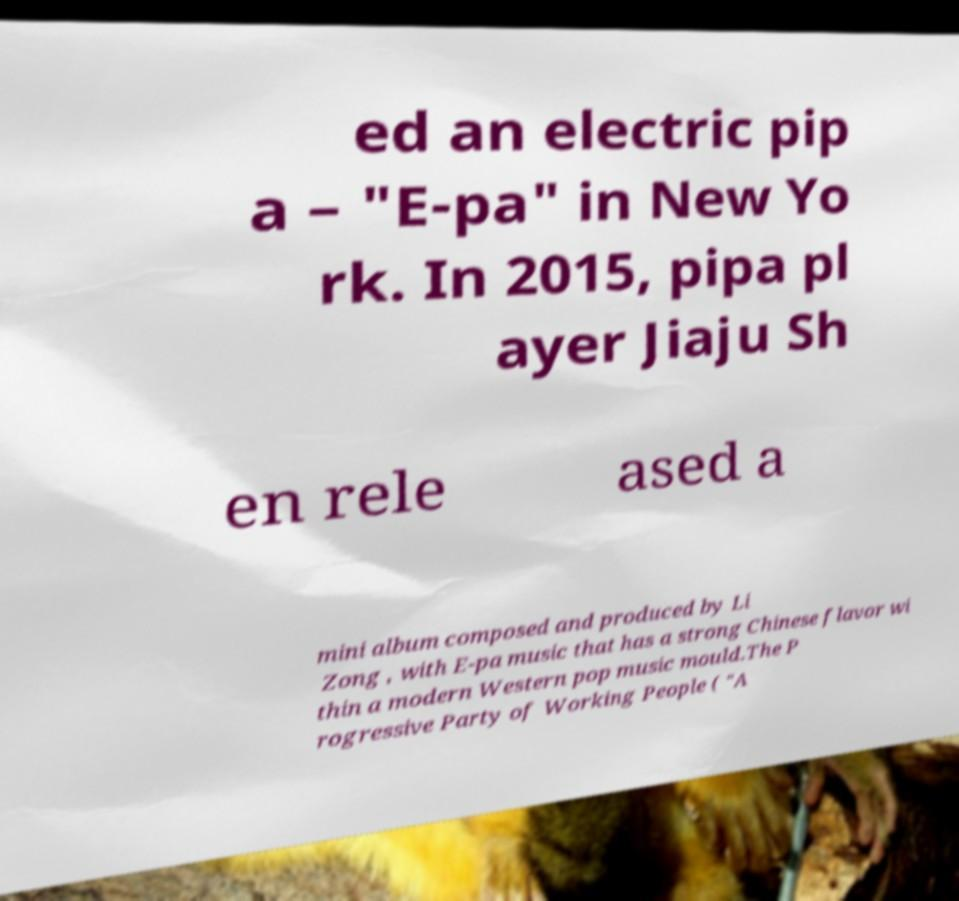I need the written content from this picture converted into text. Can you do that? ed an electric pip a – "E-pa" in New Yo rk. In 2015, pipa pl ayer Jiaju Sh en rele ased a mini album composed and produced by Li Zong , with E-pa music that has a strong Chinese flavor wi thin a modern Western pop music mould.The P rogressive Party of Working People ( "A 